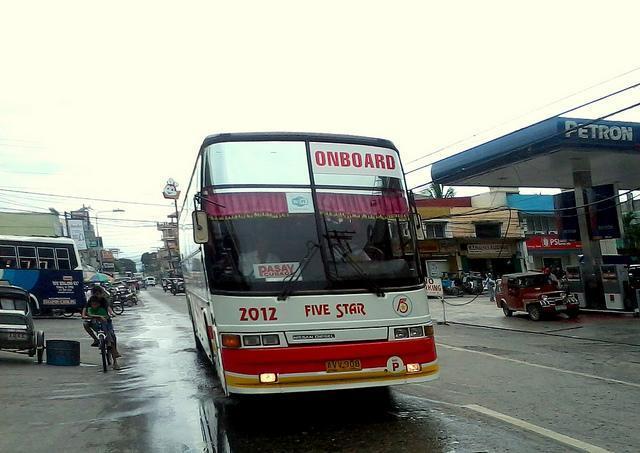How many buses are in the picture?
Give a very brief answer. 2. How many cars can you see?
Give a very brief answer. 2. How many pink books are there?
Give a very brief answer. 0. 